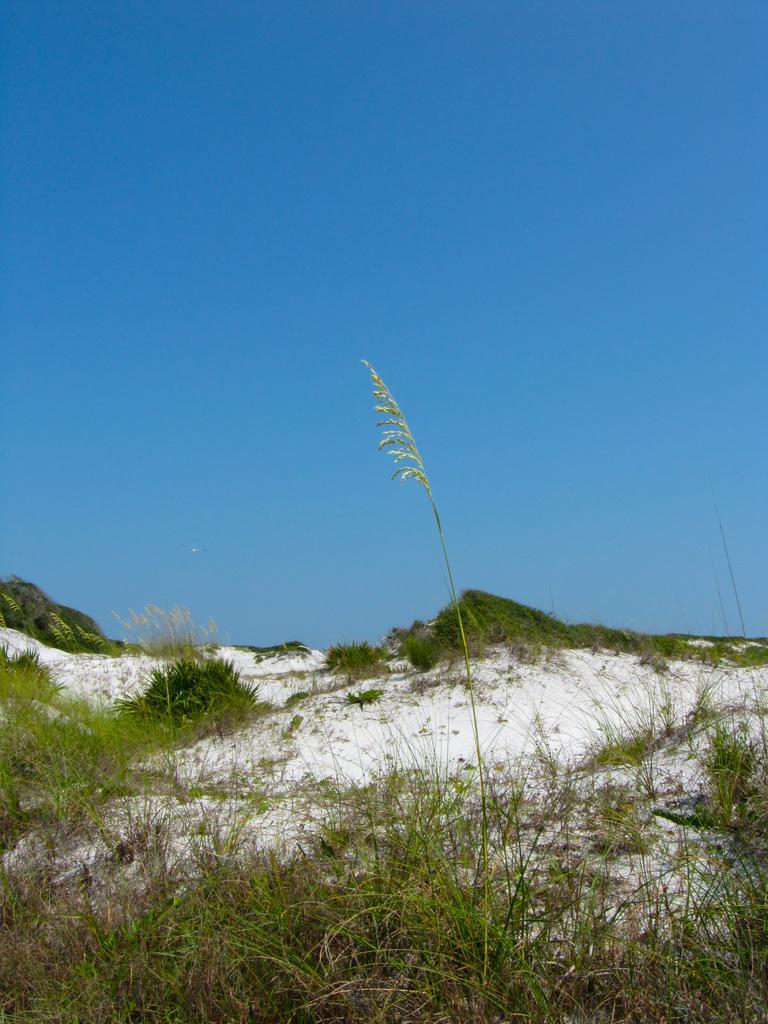Could you give a brief overview of what you see in this image? We can see grass and snow. In the background we can see sky in blue color. 